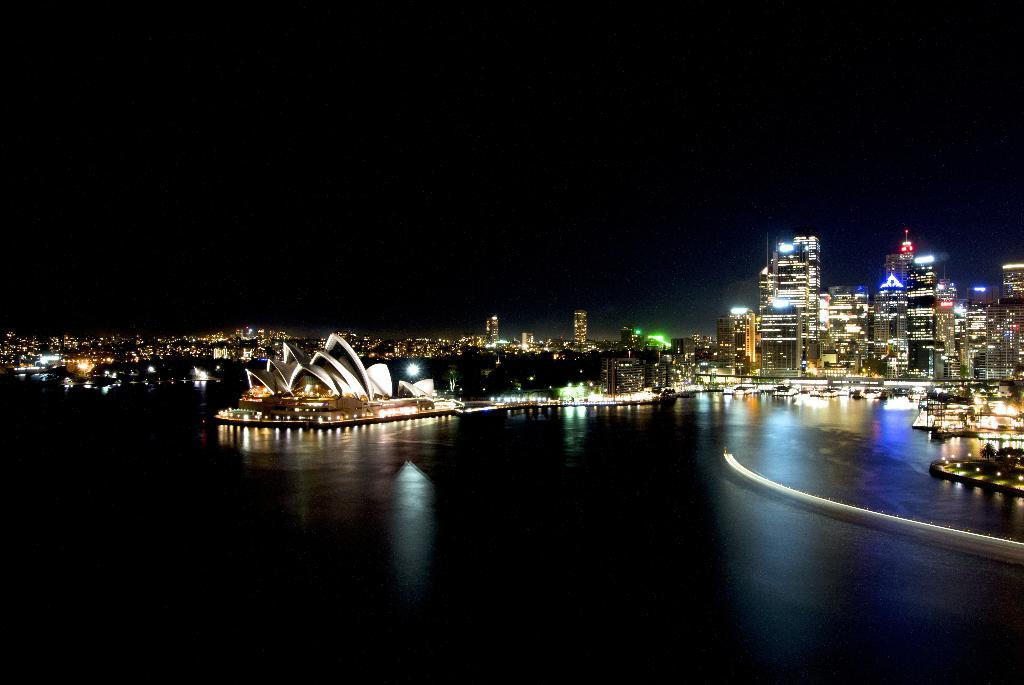What is in the water in the image? There are boats in the water in the image. What can be seen in the background of the image? There are buildings in the background of the image. How are the buildings decorated? The buildings are decorated with lights. What is the color of the sky in the image? The sky is black in color. What type of substance is being pumped out of the boats in the image? There is no indication of any substance being pumped out of the boats in the image. Are there any astronauts visible in the image? There is no mention of astronauts or space in the image; it features boats in the water and buildings in the background. 